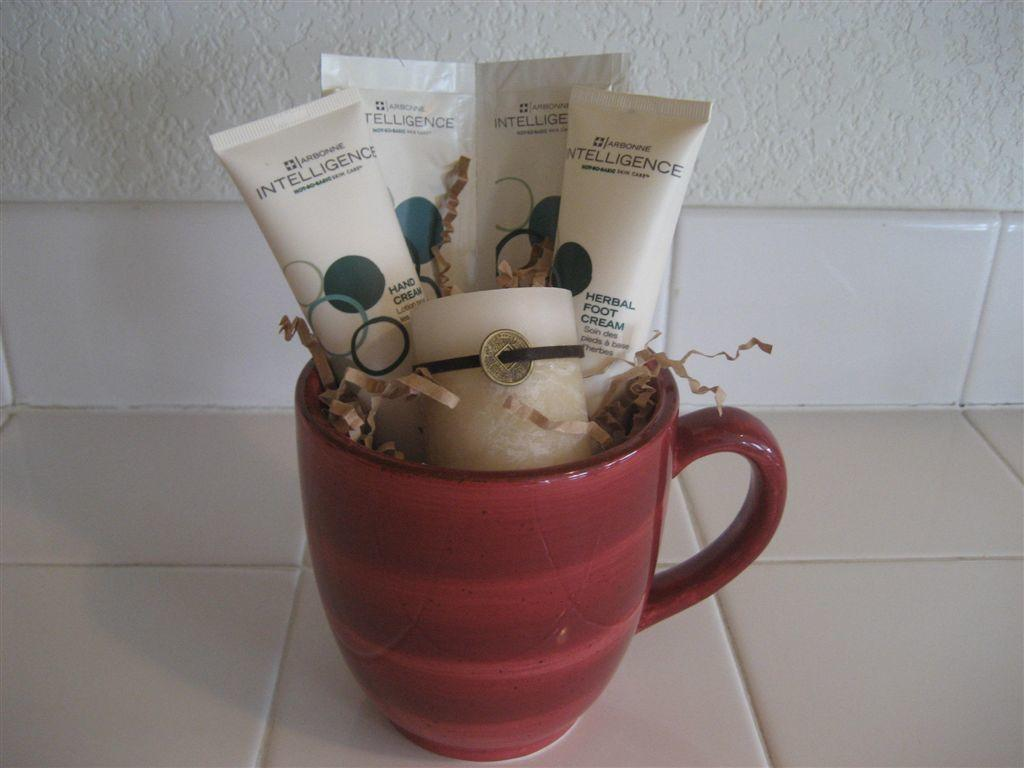What is placed in the cup in the image? There are tubes placed in a cup in the image. What can be seen in the background of the image? There is a wall in the background of the image. What type of soap is being used in the image? There is no soap present in the image; it features tubes placed in a cup and a wall in the background. How many eggs are visible in the image? There are no eggs present in the image. 